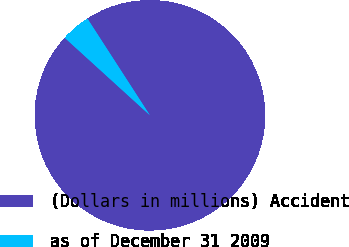Convert chart. <chart><loc_0><loc_0><loc_500><loc_500><pie_chart><fcel>(Dollars in millions) Accident<fcel>as of December 31 2009<nl><fcel>95.88%<fcel>4.12%<nl></chart> 